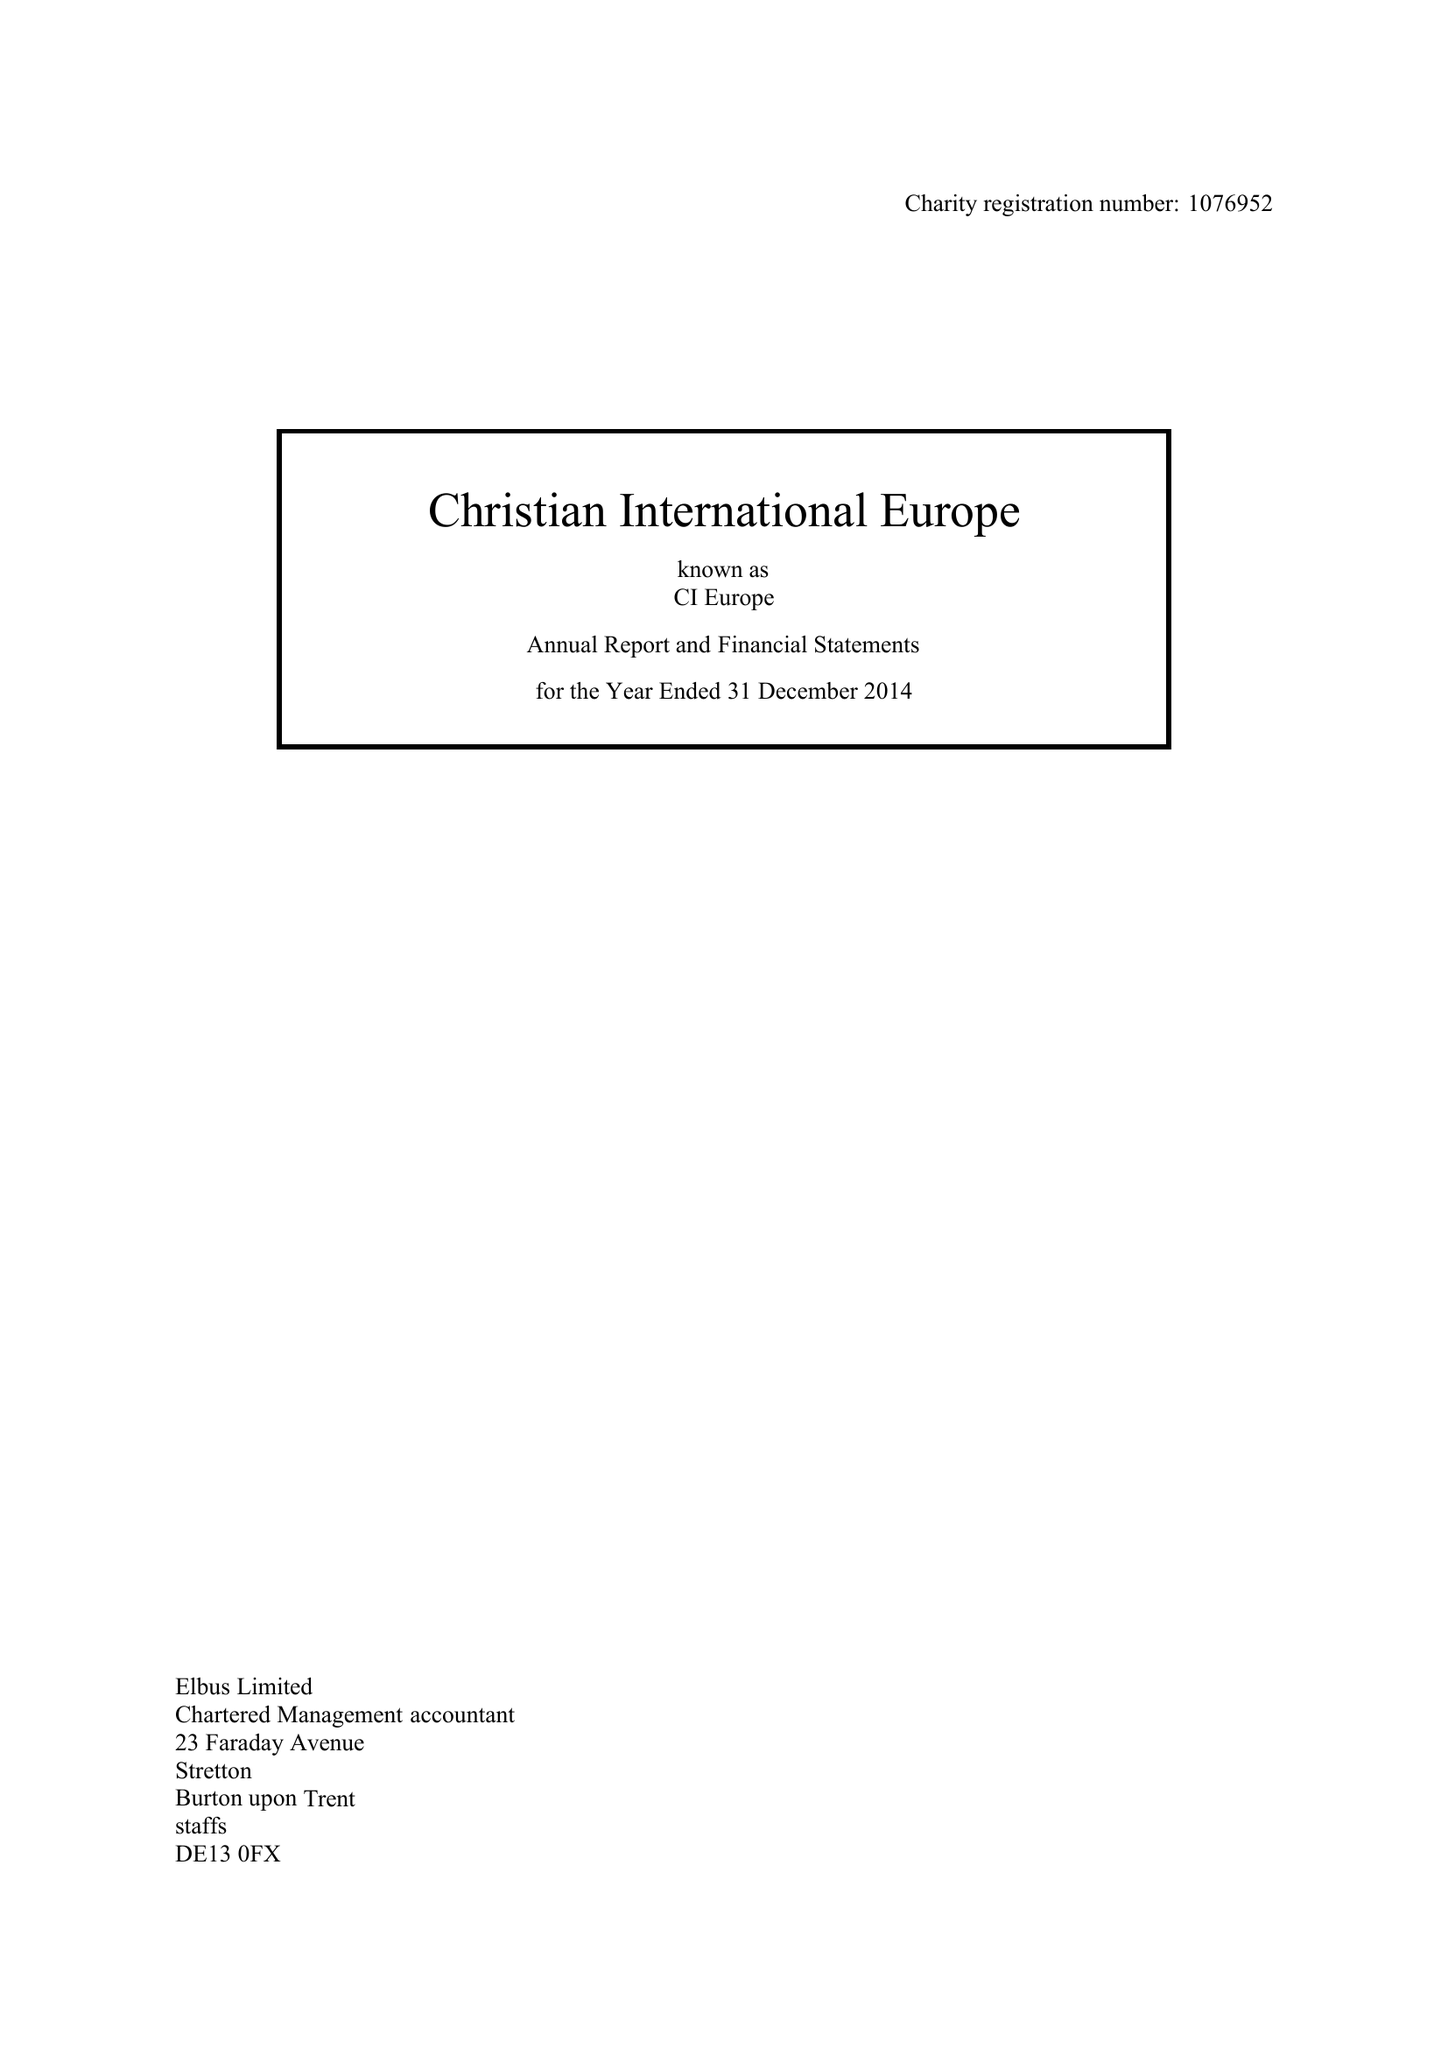What is the value for the charity_name?
Answer the question using a single word or phrase. Christian International Europe 